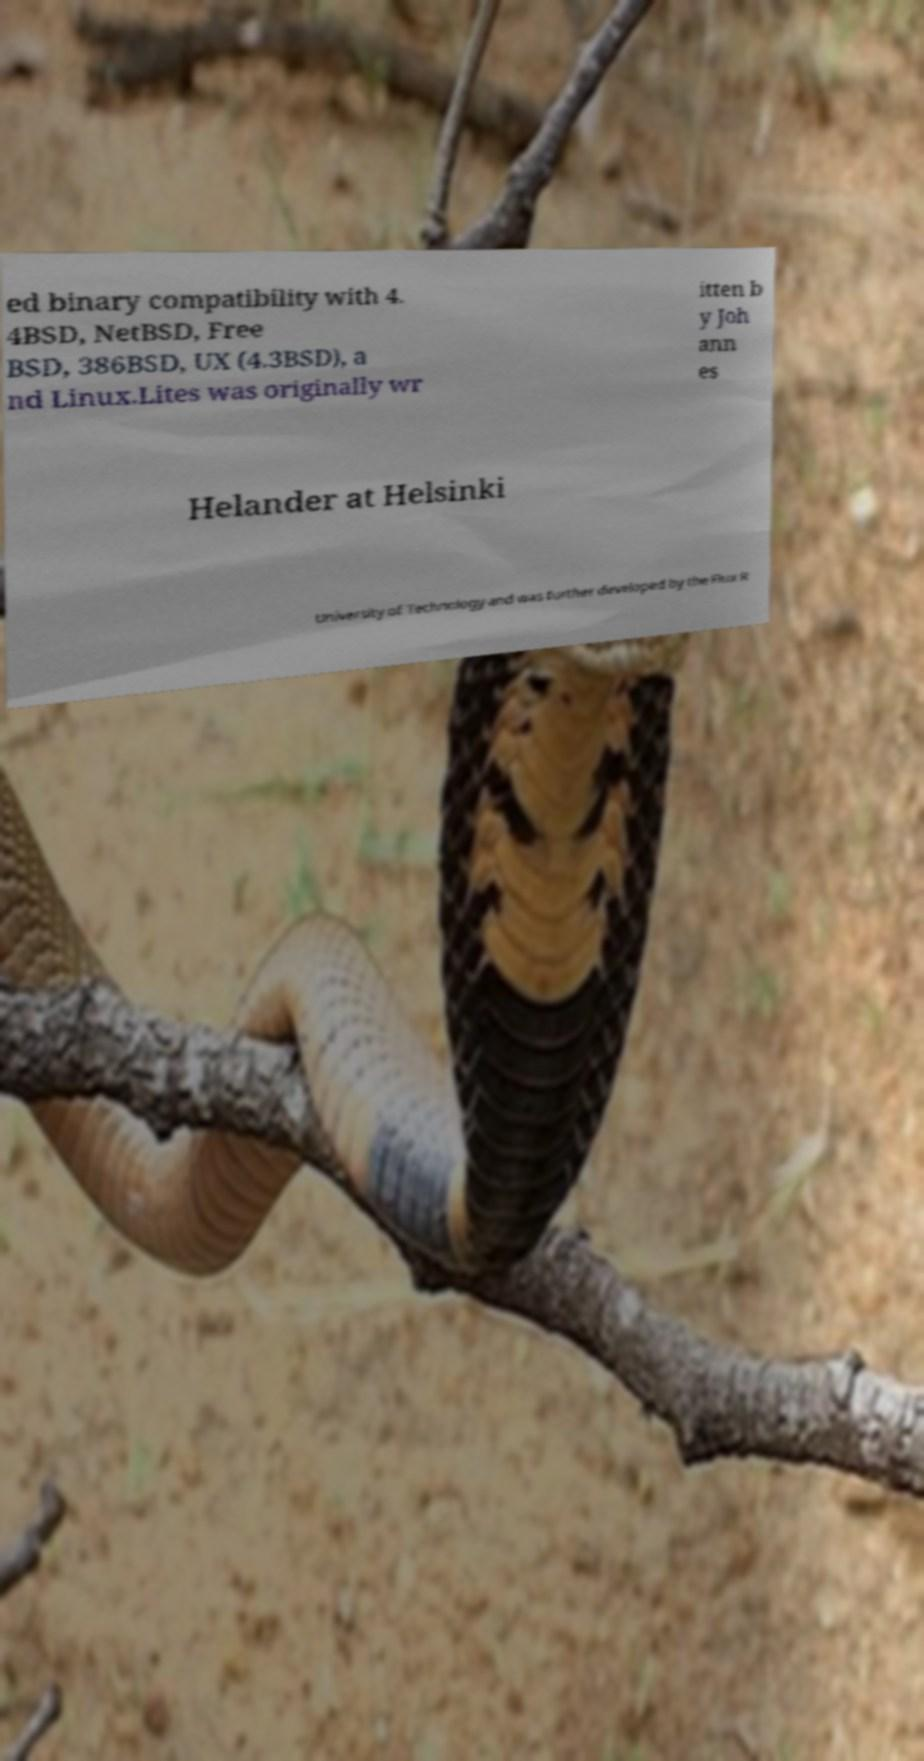For documentation purposes, I need the text within this image transcribed. Could you provide that? ed binary compatibility with 4. 4BSD, NetBSD, Free BSD, 386BSD, UX (4.3BSD), a nd Linux.Lites was originally wr itten b y Joh ann es Helander at Helsinki University of Technology and was further developed by the Flux R 